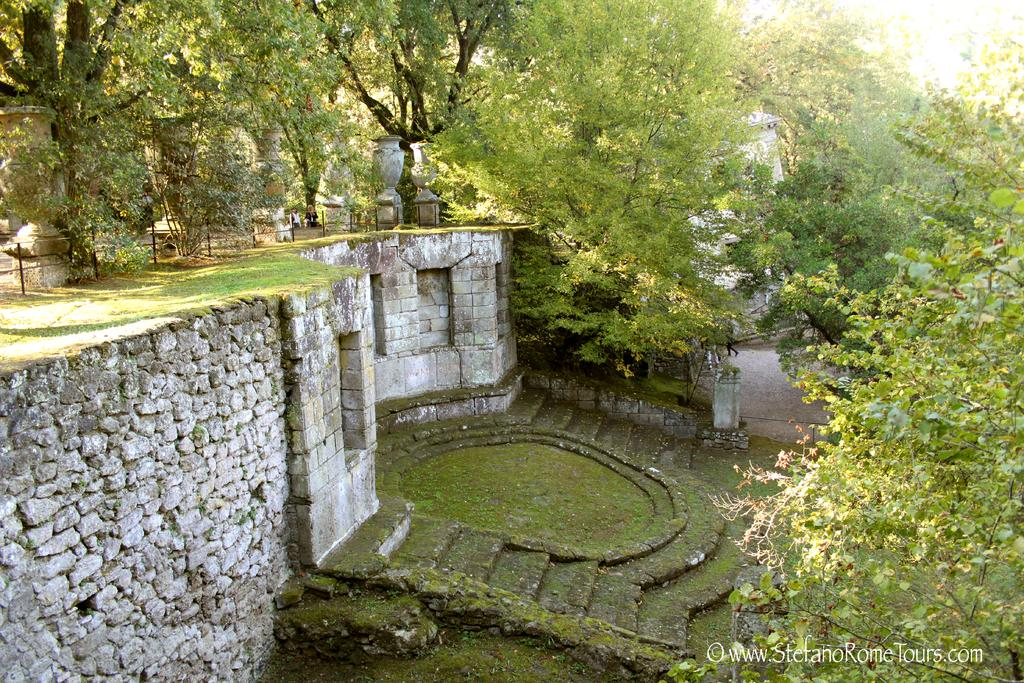What type of vegetation can be seen in the image? There are trees in the image. What type of surface is visible in the image? There is grass in the image. What is the background of the image? The sky is visible in the background of the image. What can be found at the bottom of the image? There are rocks, algae, and other objects at the bottom of the image. What type of sound can be heard coming from the apple in the image? There is no apple present in the image, so it is not possible to determine what sound might be coming from it. 